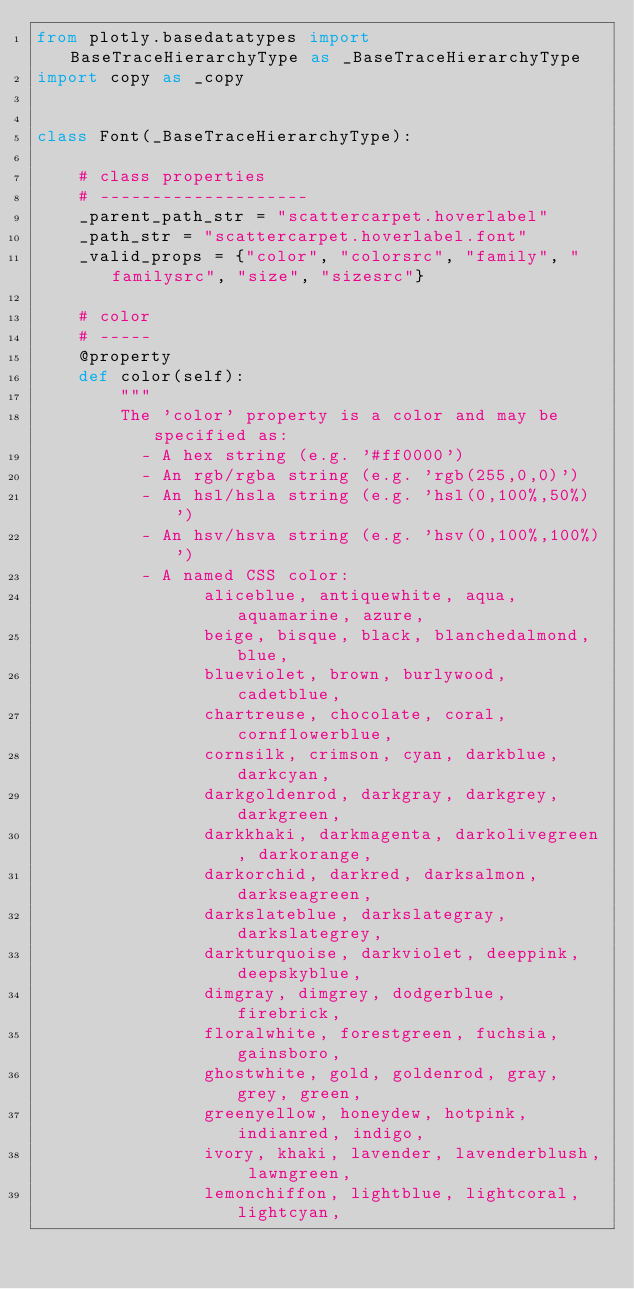Convert code to text. <code><loc_0><loc_0><loc_500><loc_500><_Python_>from plotly.basedatatypes import BaseTraceHierarchyType as _BaseTraceHierarchyType
import copy as _copy


class Font(_BaseTraceHierarchyType):

    # class properties
    # --------------------
    _parent_path_str = "scattercarpet.hoverlabel"
    _path_str = "scattercarpet.hoverlabel.font"
    _valid_props = {"color", "colorsrc", "family", "familysrc", "size", "sizesrc"}

    # color
    # -----
    @property
    def color(self):
        """
        The 'color' property is a color and may be specified as:
          - A hex string (e.g. '#ff0000')
          - An rgb/rgba string (e.g. 'rgb(255,0,0)')
          - An hsl/hsla string (e.g. 'hsl(0,100%,50%)')
          - An hsv/hsva string (e.g. 'hsv(0,100%,100%)')
          - A named CSS color:
                aliceblue, antiquewhite, aqua, aquamarine, azure,
                beige, bisque, black, blanchedalmond, blue,
                blueviolet, brown, burlywood, cadetblue,
                chartreuse, chocolate, coral, cornflowerblue,
                cornsilk, crimson, cyan, darkblue, darkcyan,
                darkgoldenrod, darkgray, darkgrey, darkgreen,
                darkkhaki, darkmagenta, darkolivegreen, darkorange,
                darkorchid, darkred, darksalmon, darkseagreen,
                darkslateblue, darkslategray, darkslategrey,
                darkturquoise, darkviolet, deeppink, deepskyblue,
                dimgray, dimgrey, dodgerblue, firebrick,
                floralwhite, forestgreen, fuchsia, gainsboro,
                ghostwhite, gold, goldenrod, gray, grey, green,
                greenyellow, honeydew, hotpink, indianred, indigo,
                ivory, khaki, lavender, lavenderblush, lawngreen,
                lemonchiffon, lightblue, lightcoral, lightcyan,</code> 